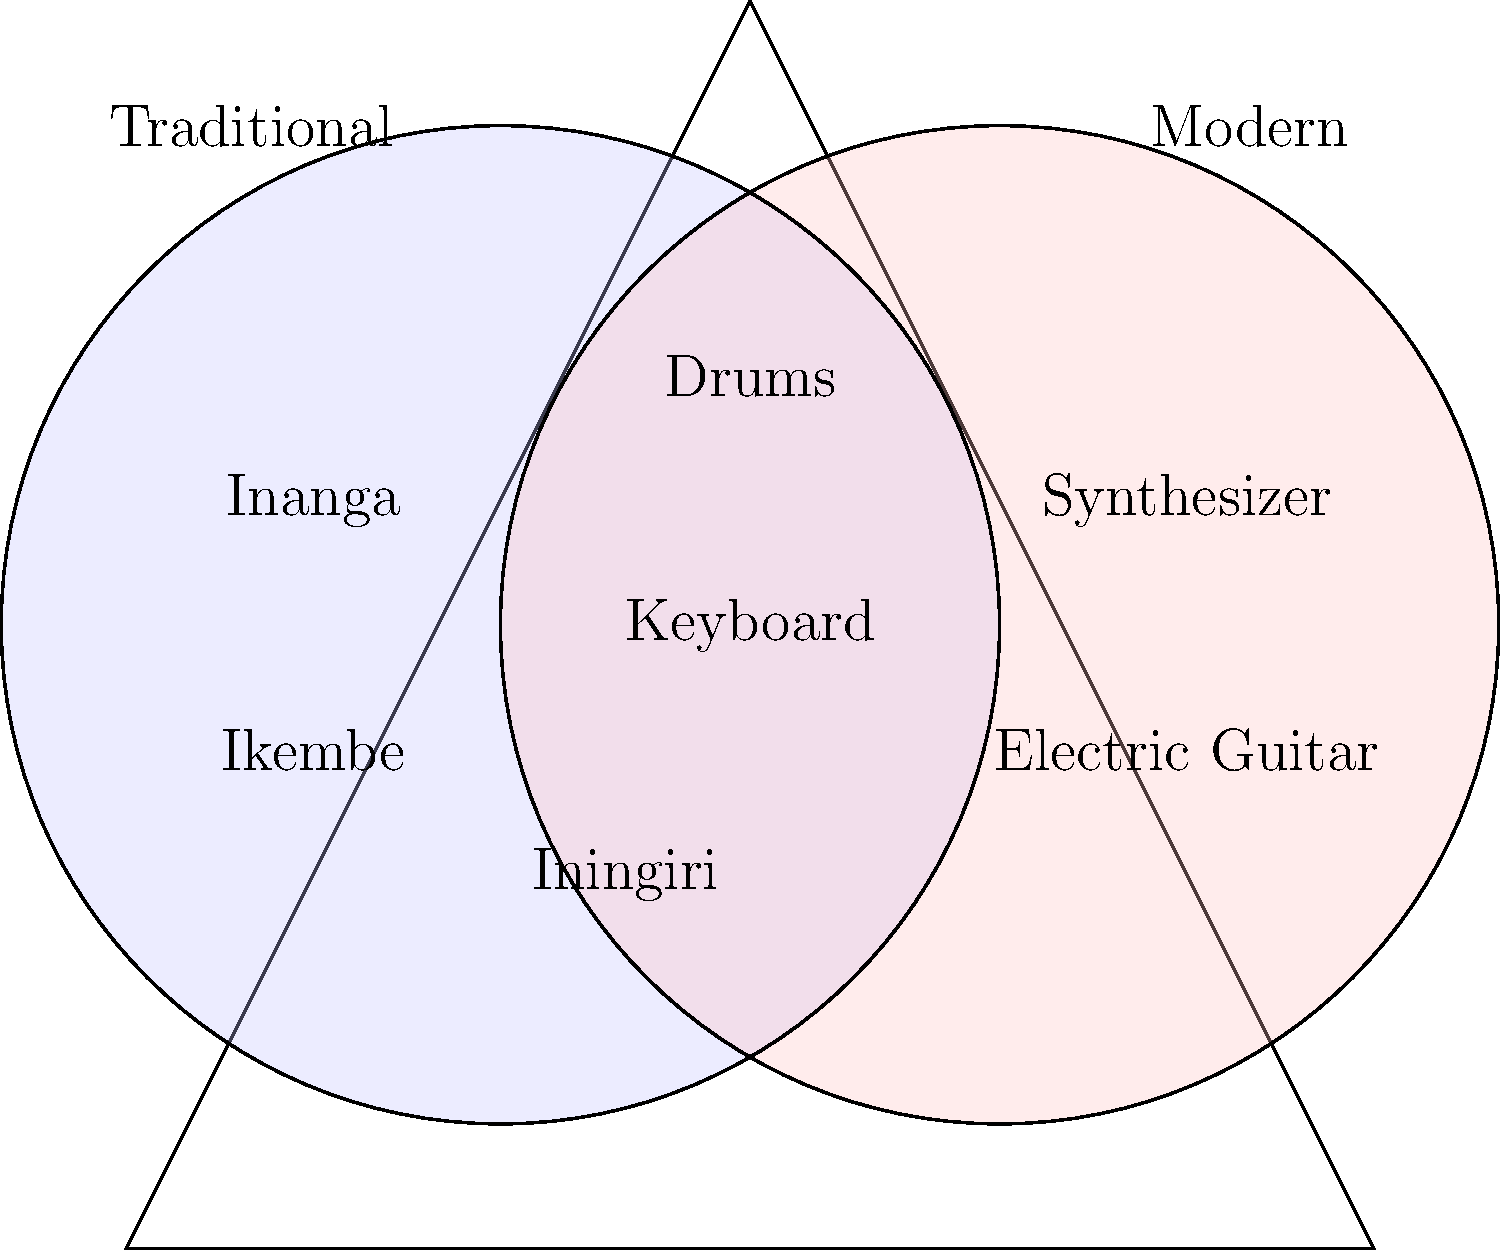Based on the Venn diagram comparing traditional Rwandan music instruments and modern instruments used in Meddy's compositions, which instruments are common to both categories? To answer this question, we need to analyze the Venn diagram carefully:

1. The left circle represents traditional Rwandan instruments, including:
   - Inanga
   - Ikembe
   - Iningiri

2. The right circle represents modern instruments used in Meddy's compositions, including:
   - Synthesizer
   - Electric Guitar

3. The overlapping area in the middle represents instruments that are common to both traditional Rwandan music and Meddy's modern compositions. In this area, we can see:
   - Drums
   - Keyboard

4. These two instruments in the overlapping area indicate that they are used in both traditional Rwandan music and Meddy's modern compositions.

5. It's important to note that while drums have been a part of traditional Rwandan music for centuries, the keyboard likely refers to a modern interpretation or adaptation of traditional melodic instruments in Meddy's music.

Therefore, the instruments common to both categories are drums and keyboard.
Answer: Drums and keyboard 